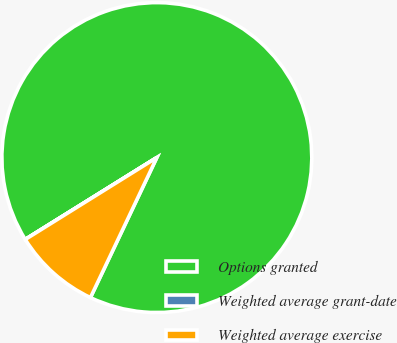<chart> <loc_0><loc_0><loc_500><loc_500><pie_chart><fcel>Options granted<fcel>Weighted average grant-date<fcel>Weighted average exercise<nl><fcel>90.9%<fcel>0.01%<fcel>9.09%<nl></chart> 